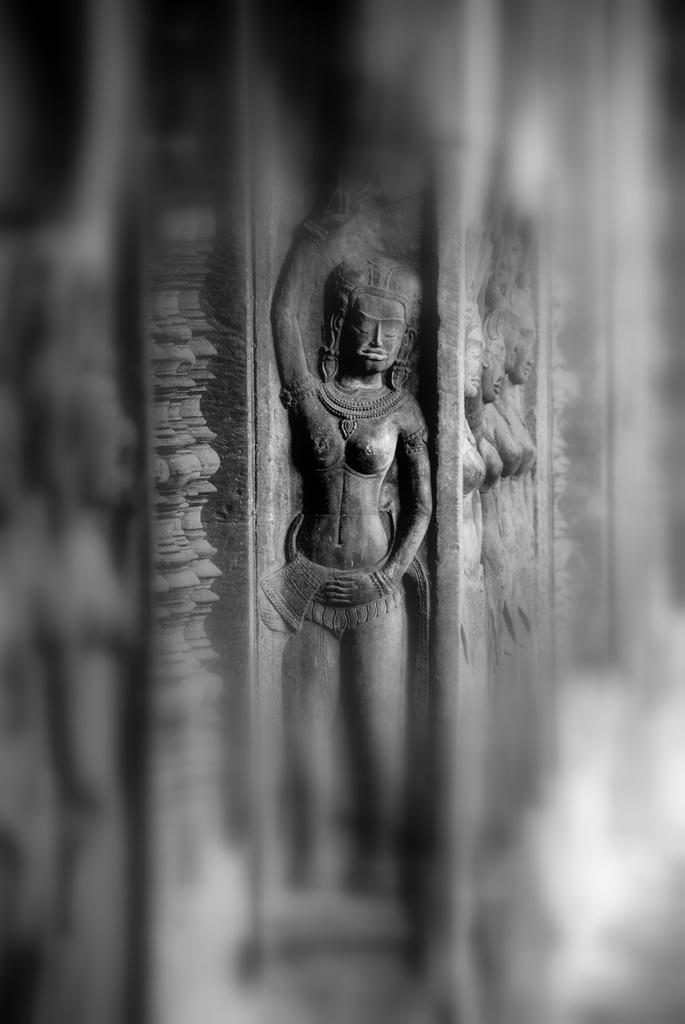Describe this image in one or two sentences. In the middle of this image I can see the sculptures on a rock. The background is blurred. 